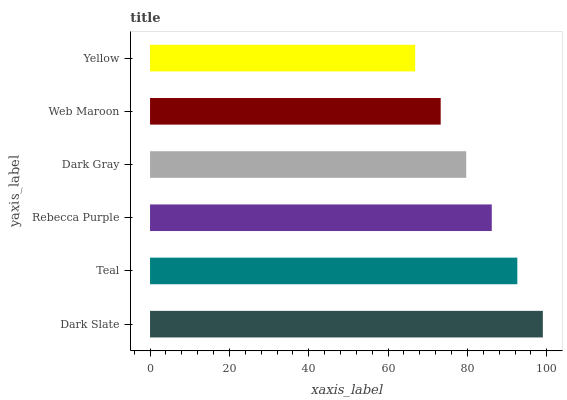Is Yellow the minimum?
Answer yes or no. Yes. Is Dark Slate the maximum?
Answer yes or no. Yes. Is Teal the minimum?
Answer yes or no. No. Is Teal the maximum?
Answer yes or no. No. Is Dark Slate greater than Teal?
Answer yes or no. Yes. Is Teal less than Dark Slate?
Answer yes or no. Yes. Is Teal greater than Dark Slate?
Answer yes or no. No. Is Dark Slate less than Teal?
Answer yes or no. No. Is Rebecca Purple the high median?
Answer yes or no. Yes. Is Dark Gray the low median?
Answer yes or no. Yes. Is Web Maroon the high median?
Answer yes or no. No. Is Yellow the low median?
Answer yes or no. No. 